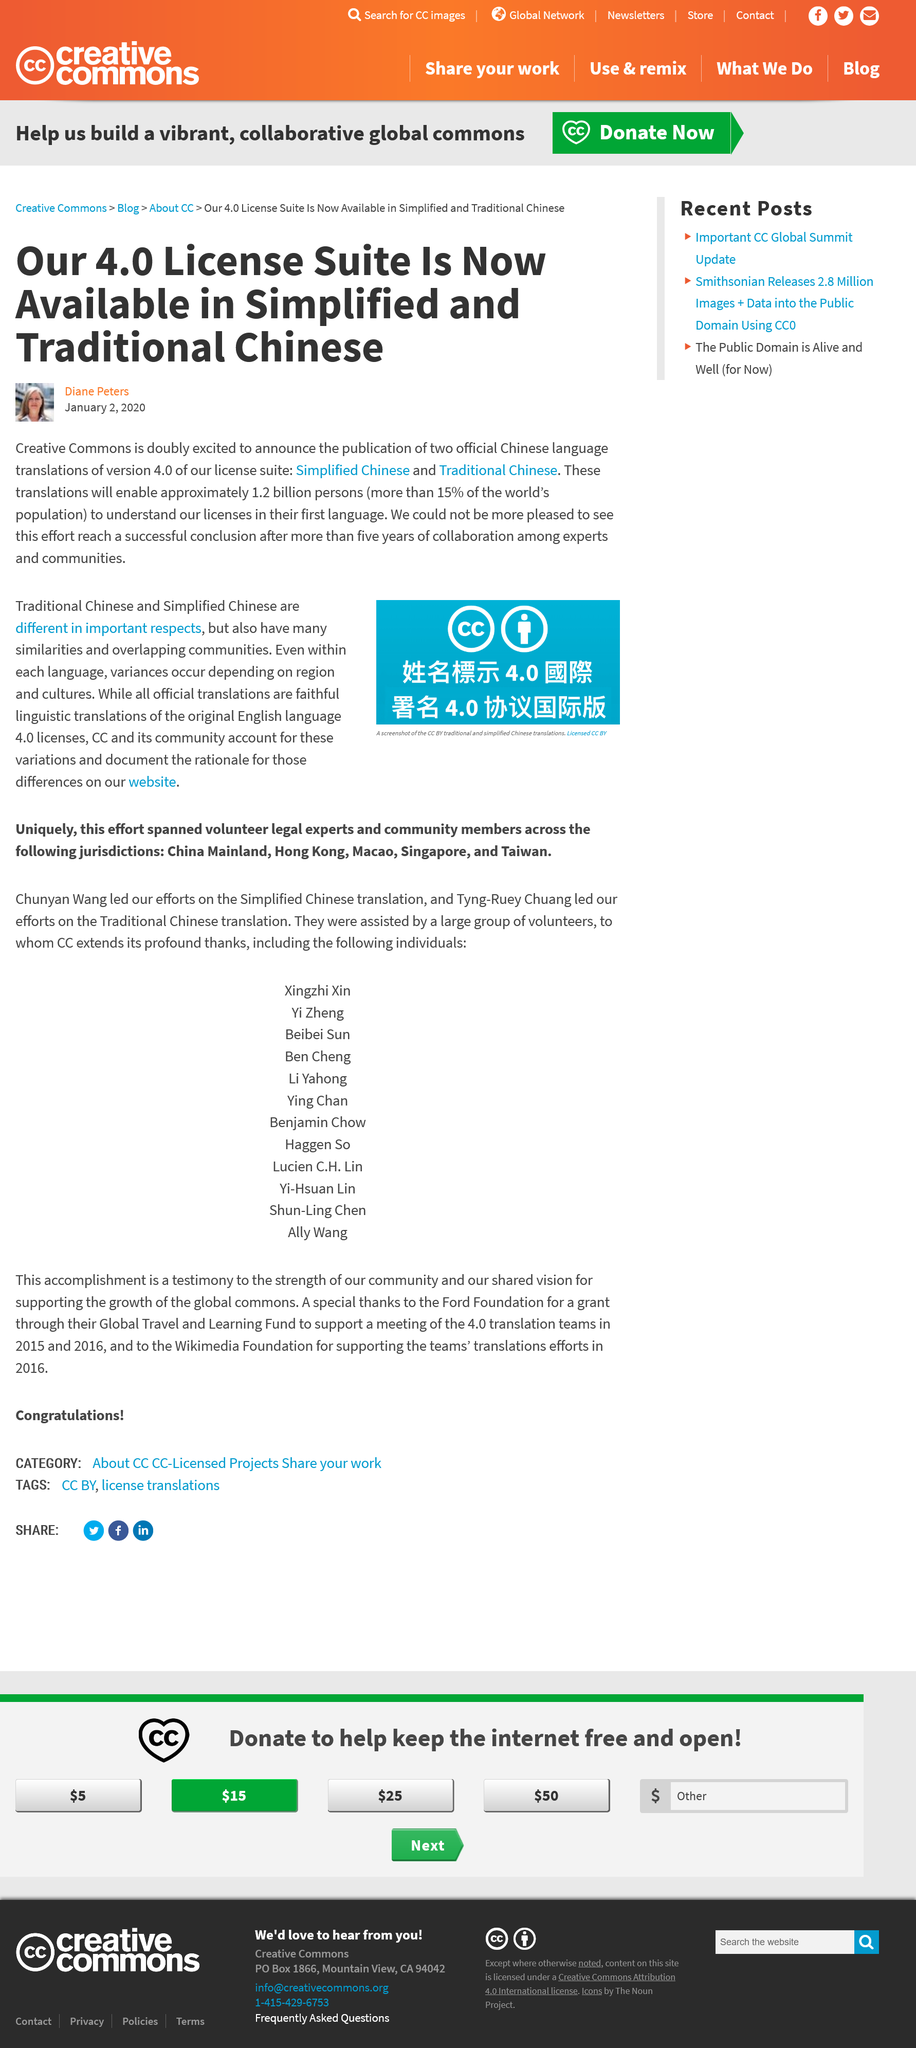Draw attention to some important aspects in this diagram. The 4.0 License Suite is now available in Simplified Chinese and Traditional Chinese. The author of the article is Diane Peters. Our software translations will enable over 1.2 billion people to understand the license in their first language, making it more accessible to a large portion of the global population. 